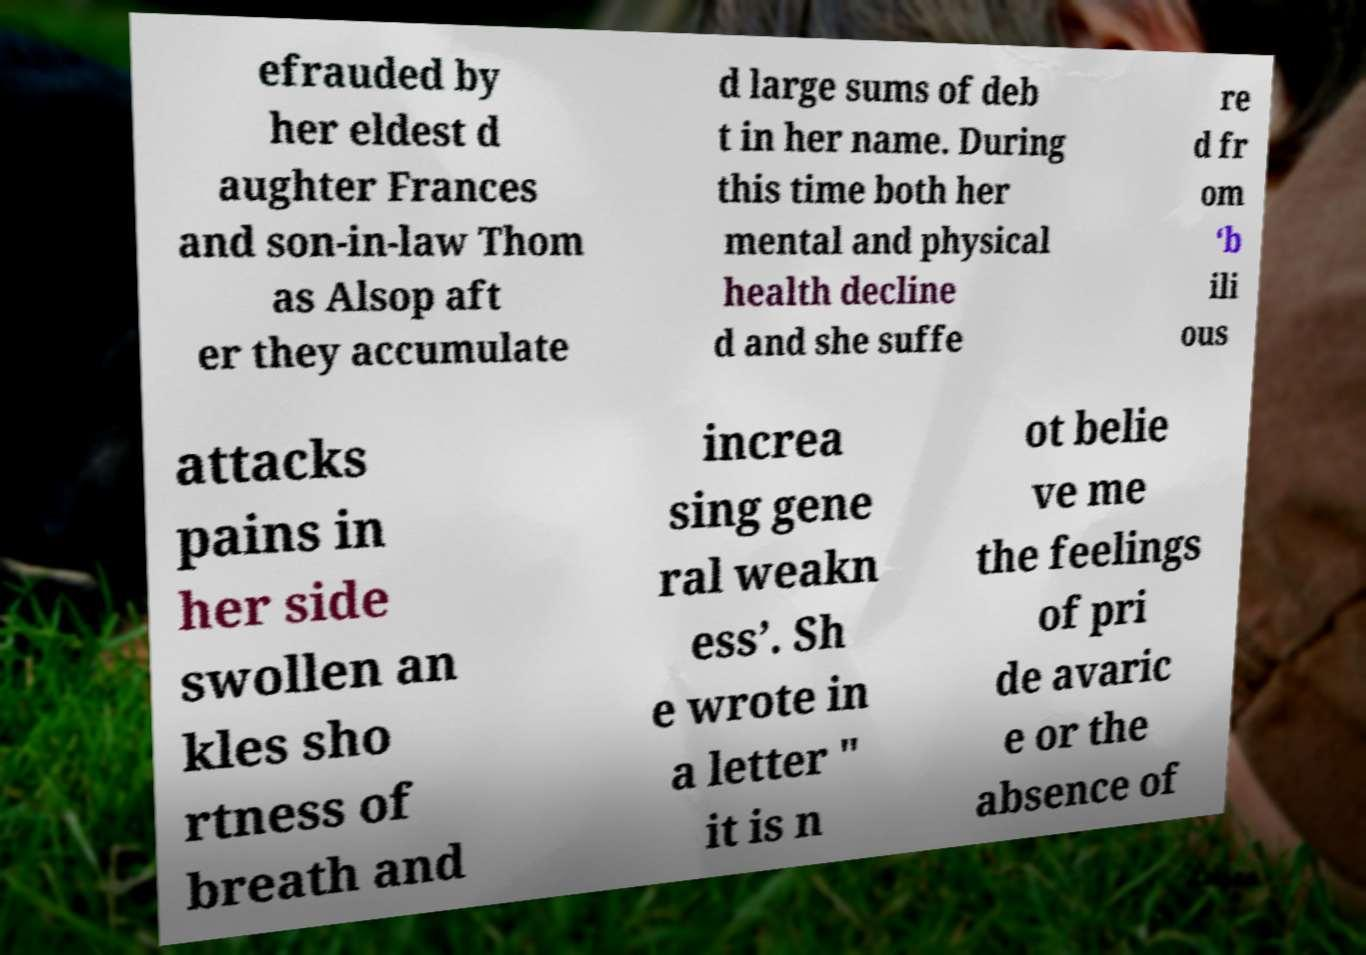I need the written content from this picture converted into text. Can you do that? efrauded by her eldest d aughter Frances and son-in-law Thom as Alsop aft er they accumulate d large sums of deb t in her name. During this time both her mental and physical health decline d and she suffe re d fr om ‘b ili ous attacks pains in her side swollen an kles sho rtness of breath and increa sing gene ral weakn ess’. Sh e wrote in a letter " it is n ot belie ve me the feelings of pri de avaric e or the absence of 